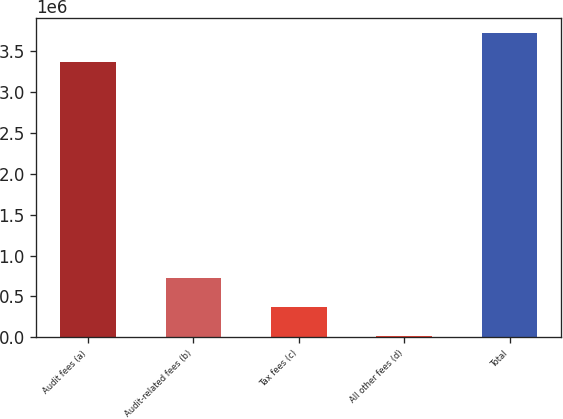<chart> <loc_0><loc_0><loc_500><loc_500><bar_chart><fcel>Audit fees (a)<fcel>Audit-related fees (b)<fcel>Tax fees (c)<fcel>All other fees (d)<fcel>Total<nl><fcel>3.364e+06<fcel>726600<fcel>368300<fcel>10000<fcel>3.7223e+06<nl></chart> 